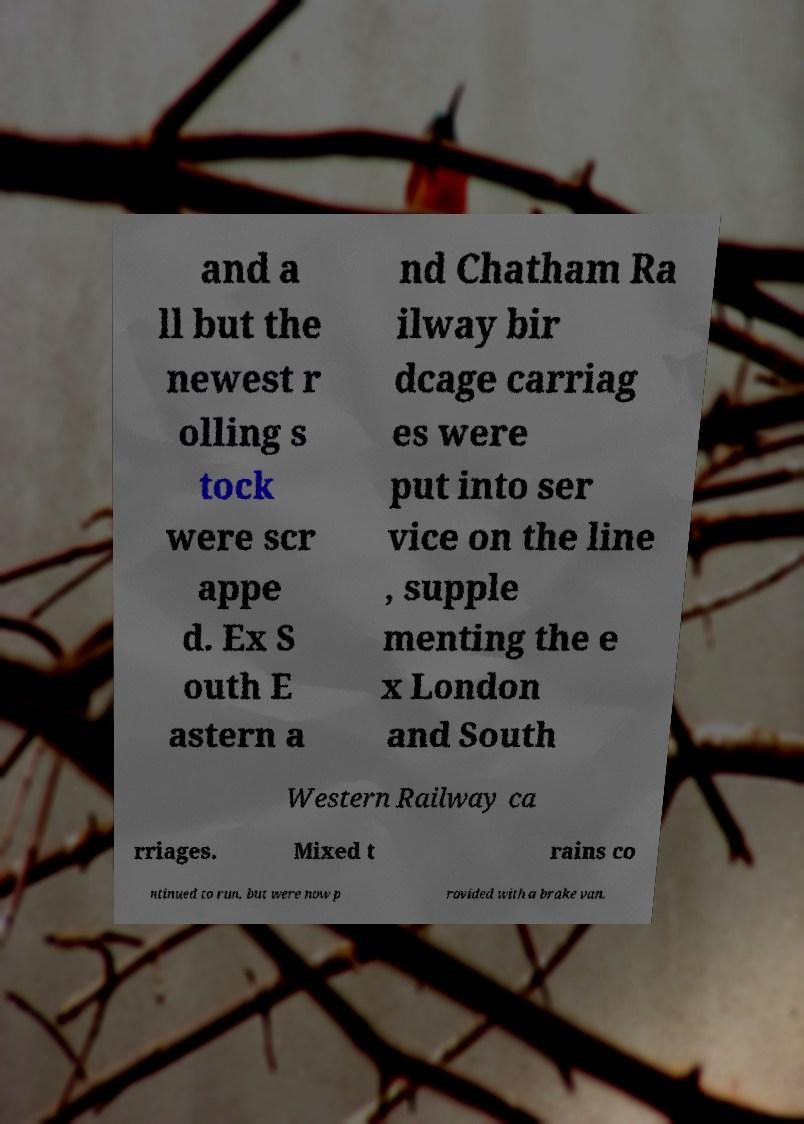What messages or text are displayed in this image? I need them in a readable, typed format. and a ll but the newest r olling s tock were scr appe d. Ex S outh E astern a nd Chatham Ra ilway bir dcage carriag es were put into ser vice on the line , supple menting the e x London and South Western Railway ca rriages. Mixed t rains co ntinued to run, but were now p rovided with a brake van. 